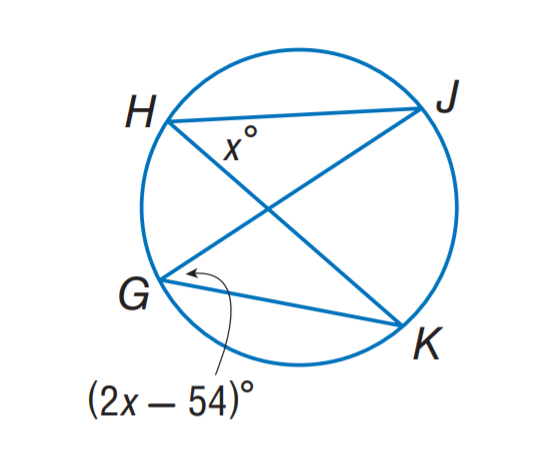Answer the mathemtical geometry problem and directly provide the correct option letter.
Question: Find m \angle H.
Choices: A: 40 B: 44 C: 48 D: 54 D 